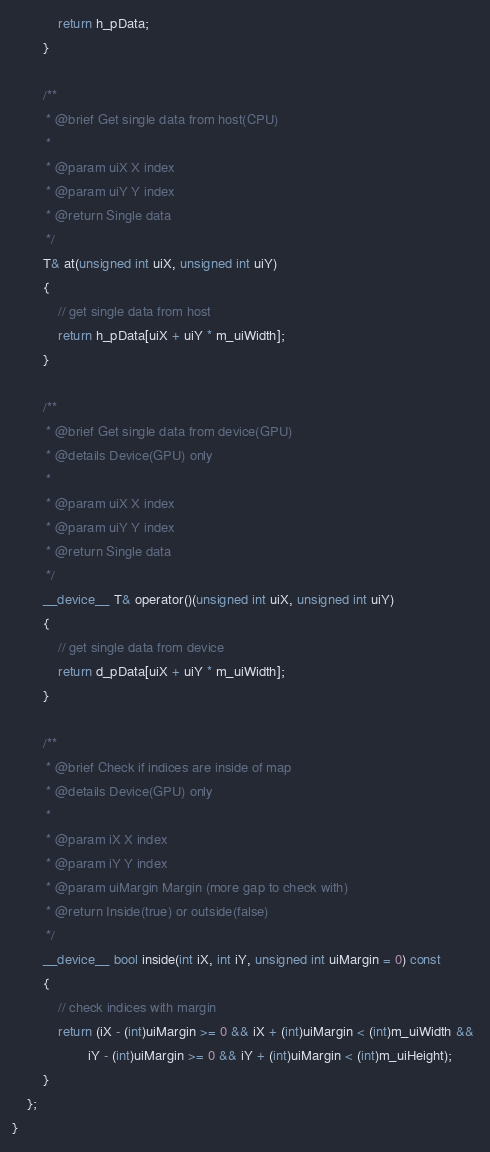Convert code to text. <code><loc_0><loc_0><loc_500><loc_500><_Cuda_>            return h_pData;
        }

        /**
         * @brief Get single data from host(CPU)
         * 
         * @param uiX X index
         * @param uiY Y index
         * @return Single data
         */
        T& at(unsigned int uiX, unsigned int uiY)
        {
            // get single data from host
            return h_pData[uiX + uiY * m_uiWidth];
        }

        /**
         * @brief Get single data from device(GPU)
         * @details Device(GPU) only
         * 
         * @param uiX X index
         * @param uiY Y index
         * @return Single data
         */
        __device__ T& operator()(unsigned int uiX, unsigned int uiY)
        {
            // get single data from device
            return d_pData[uiX + uiY * m_uiWidth];
        }

        /**
         * @brief Check if indices are inside of map
         * @details Device(GPU) only
         * 
         * @param iX X index
         * @param iY Y index
         * @param uiMargin Margin (more gap to check with)
         * @return Inside(true) or outside(false) 
         */
        __device__ bool inside(int iX, int iY, unsigned int uiMargin = 0) const
        {
            // check indices with margin
            return (iX - (int)uiMargin >= 0 && iX + (int)uiMargin < (int)m_uiWidth && 
                    iY - (int)uiMargin >= 0 && iY + (int)uiMargin < (int)m_uiHeight);
        }
    };
}
</code> 